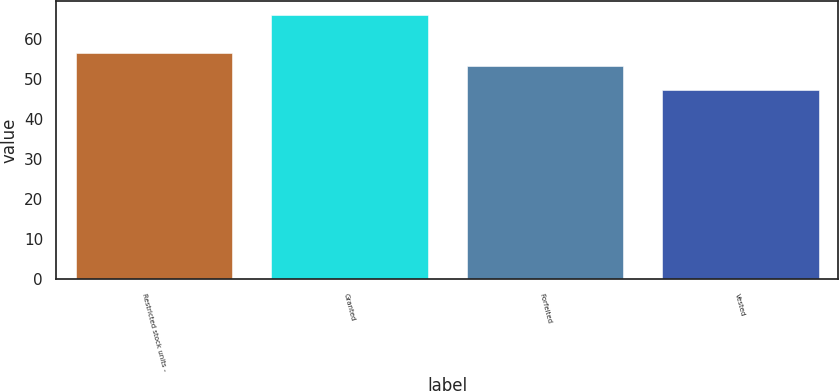Convert chart to OTSL. <chart><loc_0><loc_0><loc_500><loc_500><bar_chart><fcel>Restricted stock units -<fcel>Granted<fcel>Forfeited<fcel>Vested<nl><fcel>56.34<fcel>65.98<fcel>53.15<fcel>47.14<nl></chart> 